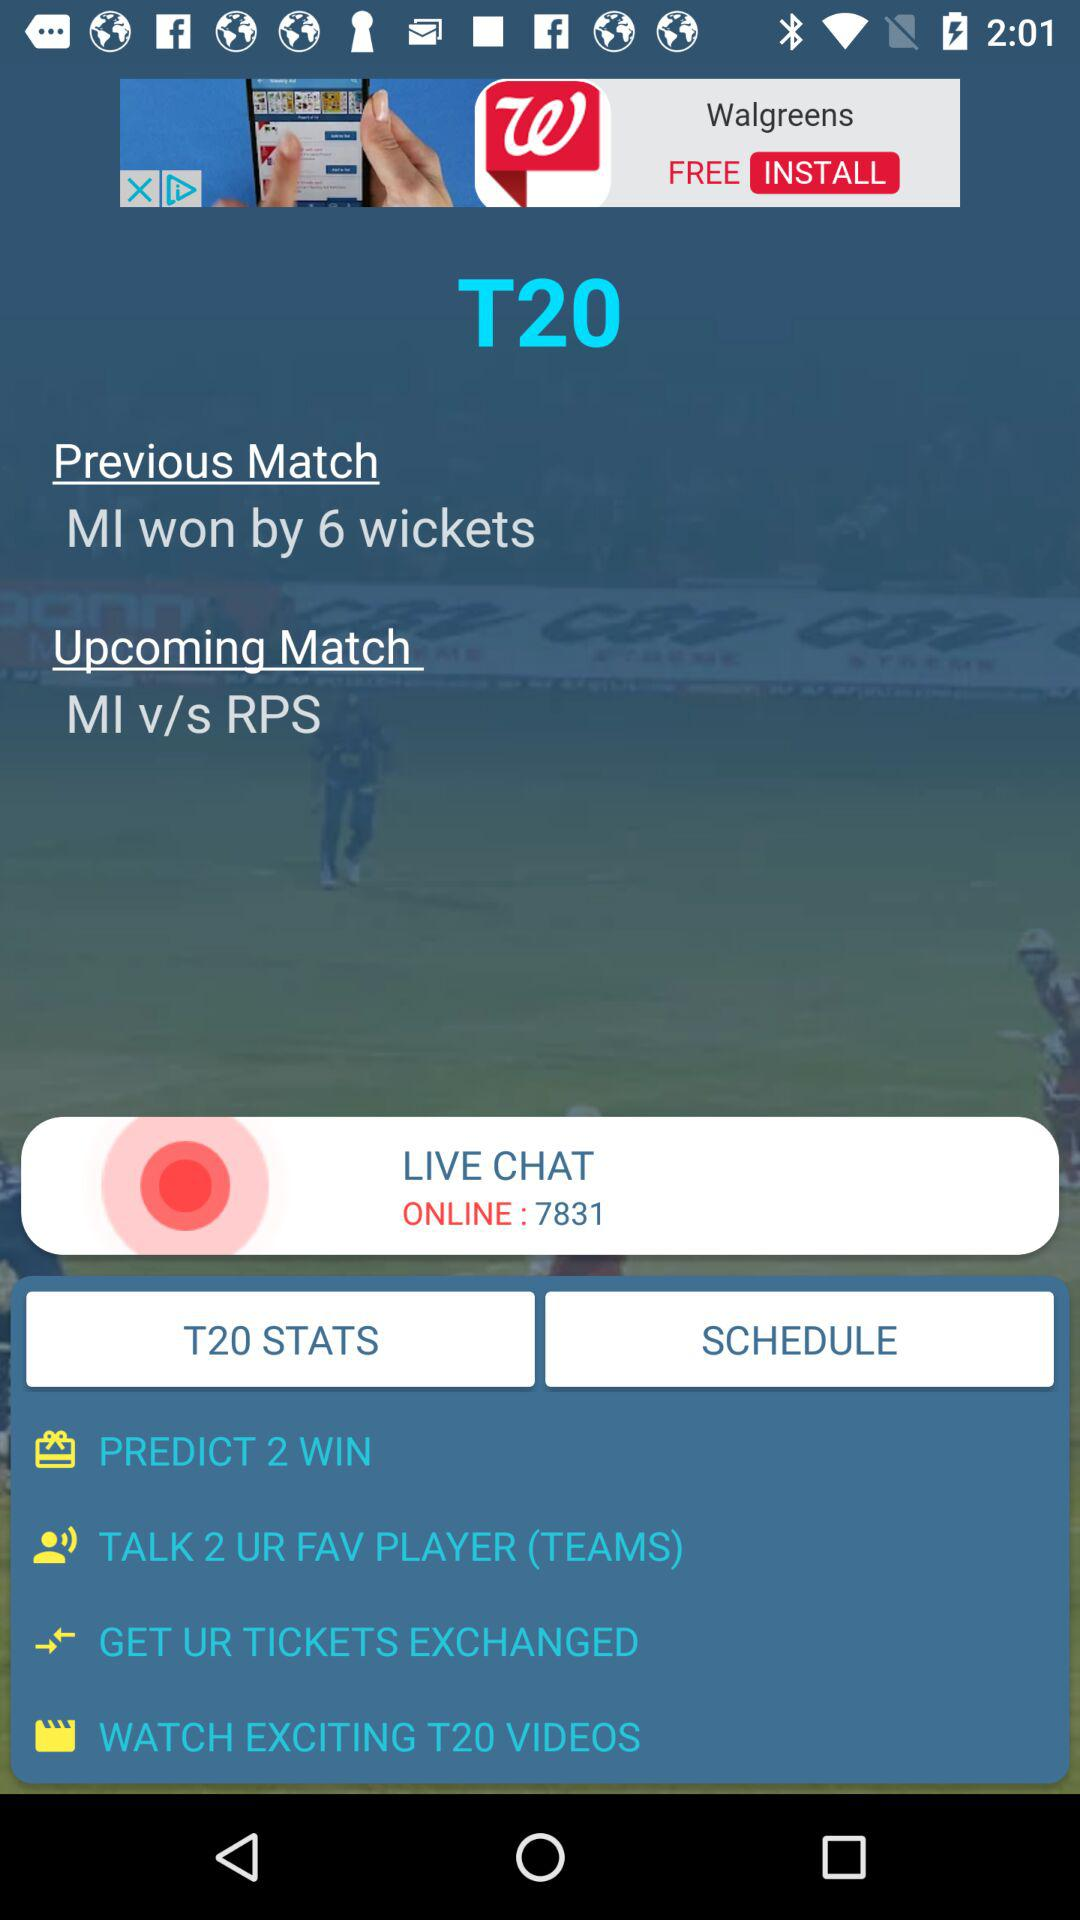Which teams will compete in the upcoming match? The teams that will compete in the upcoming match are "MI" and "RPS". 